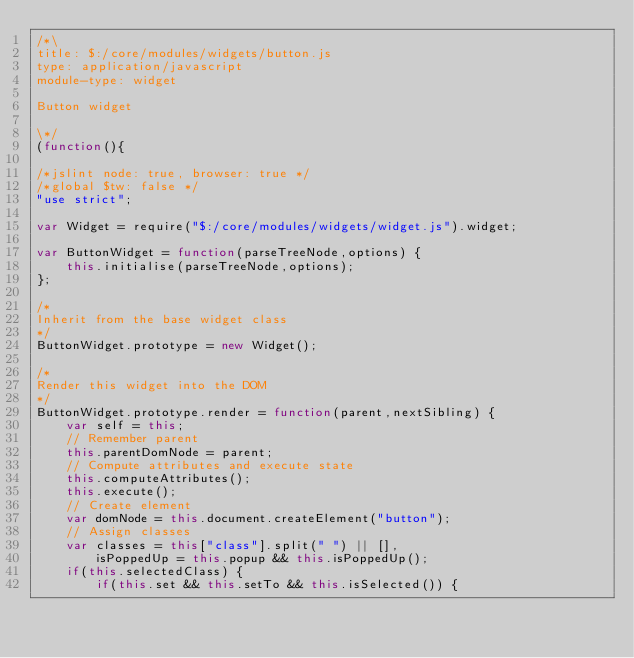<code> <loc_0><loc_0><loc_500><loc_500><_JavaScript_>/*\
title: $:/core/modules/widgets/button.js
type: application/javascript
module-type: widget

Button widget

\*/
(function(){

/*jslint node: true, browser: true */
/*global $tw: false */
"use strict";

var Widget = require("$:/core/modules/widgets/widget.js").widget;

var ButtonWidget = function(parseTreeNode,options) {
	this.initialise(parseTreeNode,options);
};

/*
Inherit from the base widget class
*/
ButtonWidget.prototype = new Widget();

/*
Render this widget into the DOM
*/
ButtonWidget.prototype.render = function(parent,nextSibling) {
	var self = this;
	// Remember parent
	this.parentDomNode = parent;
	// Compute attributes and execute state
	this.computeAttributes();
	this.execute();
	// Create element
	var domNode = this.document.createElement("button");
	// Assign classes
	var classes = this["class"].split(" ") || [],
		isPoppedUp = this.popup && this.isPoppedUp();
	if(this.selectedClass) {
		if(this.set && this.setTo && this.isSelected()) {</code> 